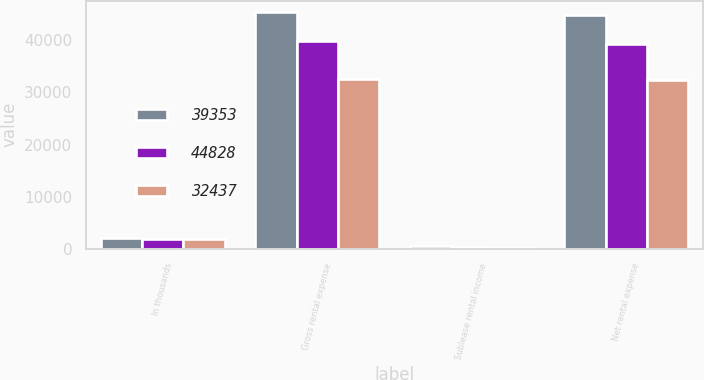Convert chart. <chart><loc_0><loc_0><loc_500><loc_500><stacked_bar_chart><ecel><fcel>In thousands<fcel>Gross rental expense<fcel>Sublease rental income<fcel>Net rental expense<nl><fcel>39353<fcel>2012<fcel>45327<fcel>499<fcel>44828<nl><fcel>44828<fcel>2011<fcel>39808<fcel>455<fcel>39353<nl><fcel>32437<fcel>2010<fcel>32662<fcel>225<fcel>32437<nl></chart> 